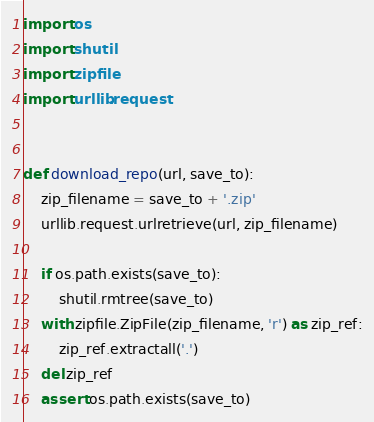<code> <loc_0><loc_0><loc_500><loc_500><_Python_>import os
import shutil
import zipfile
import urllib.request


def download_repo(url, save_to):
    zip_filename = save_to + '.zip'
    urllib.request.urlretrieve(url, zip_filename)

    if os.path.exists(save_to):
        shutil.rmtree(save_to)
    with zipfile.ZipFile(zip_filename, 'r') as zip_ref:
        zip_ref.extractall('.')
    del zip_ref
    assert os.path.exists(save_to)
</code> 